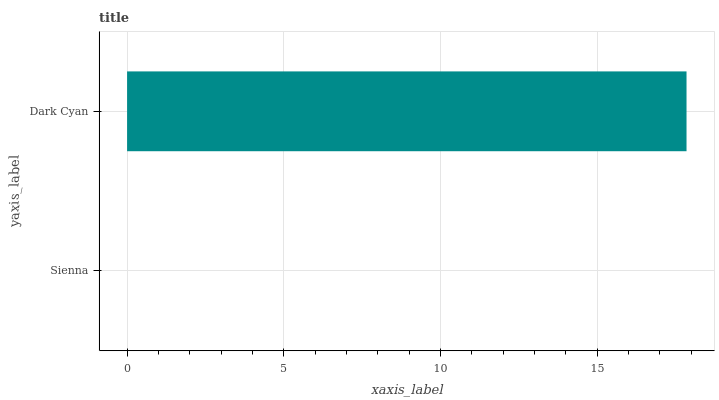Is Sienna the minimum?
Answer yes or no. Yes. Is Dark Cyan the maximum?
Answer yes or no. Yes. Is Dark Cyan the minimum?
Answer yes or no. No. Is Dark Cyan greater than Sienna?
Answer yes or no. Yes. Is Sienna less than Dark Cyan?
Answer yes or no. Yes. Is Sienna greater than Dark Cyan?
Answer yes or no. No. Is Dark Cyan less than Sienna?
Answer yes or no. No. Is Dark Cyan the high median?
Answer yes or no. Yes. Is Sienna the low median?
Answer yes or no. Yes. Is Sienna the high median?
Answer yes or no. No. Is Dark Cyan the low median?
Answer yes or no. No. 